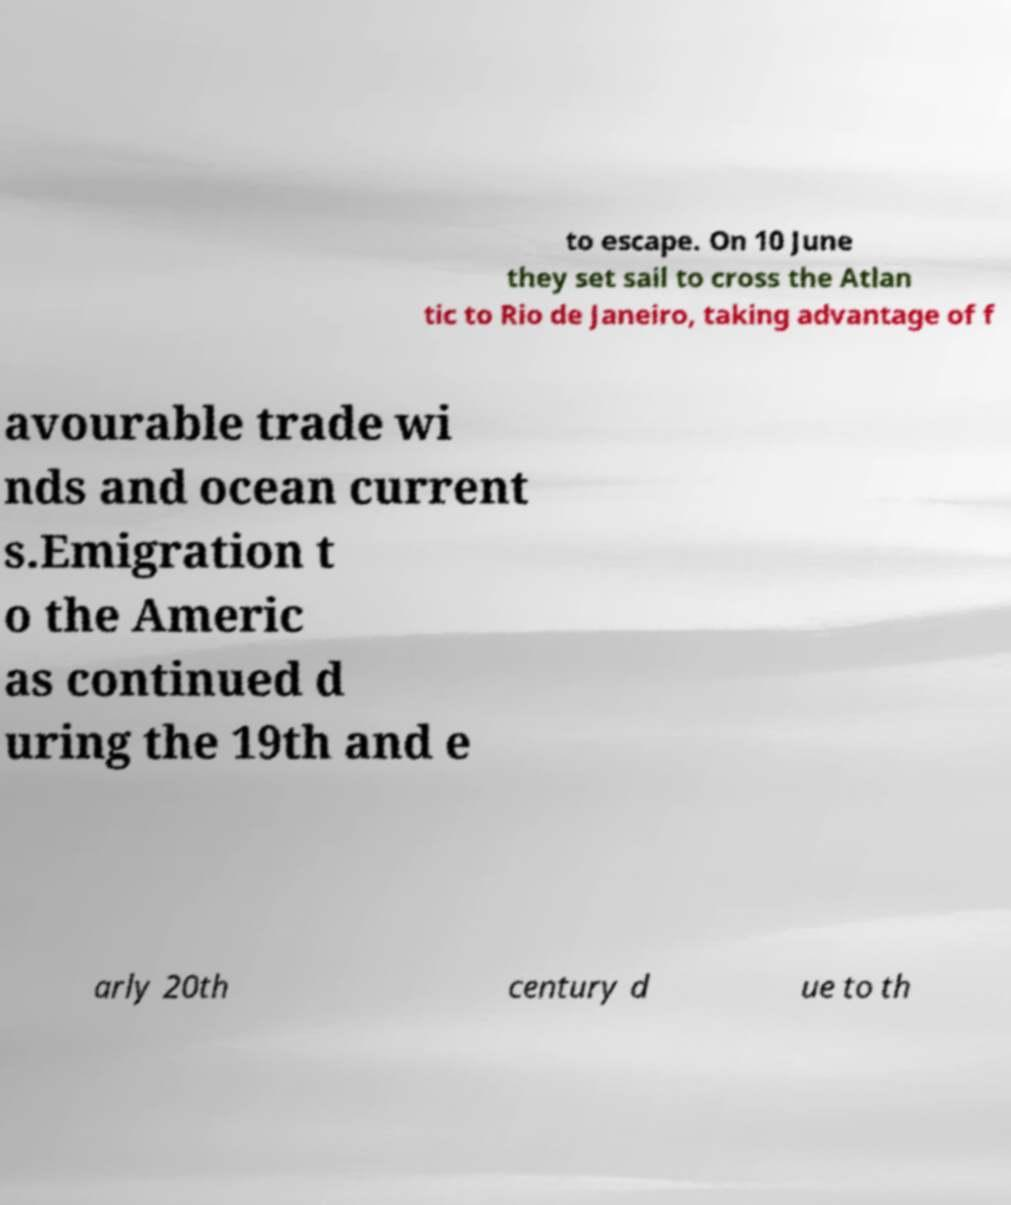Please identify and transcribe the text found in this image. to escape. On 10 June they set sail to cross the Atlan tic to Rio de Janeiro, taking advantage of f avourable trade wi nds and ocean current s.Emigration t o the Americ as continued d uring the 19th and e arly 20th century d ue to th 